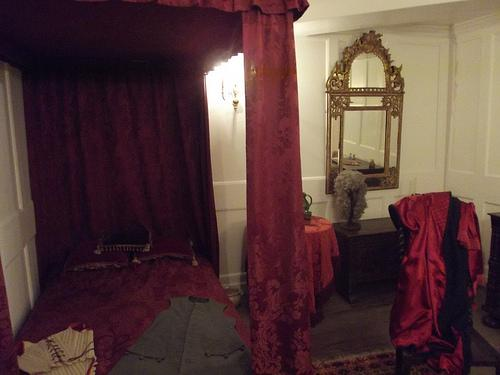Question: where was this picture taken?
Choices:
A. A bedroom.
B. A railroad station.
C. In the park.
D. Madison Square Garden..
Answer with the letter. Answer: A Question: what color is the mirror?
Choices:
A. Silver.
B. Red.
C. Gold.
D. Black.
Answer with the letter. Answer: C Question: how many pillows are shown?
Choices:
A. 6.
B. 3.
C. 7.
D. 8.
Answer with the letter. Answer: B 